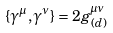Convert formula to latex. <formula><loc_0><loc_0><loc_500><loc_500>\{ \gamma ^ { \mu } , \gamma ^ { \nu } \} = 2 g ^ { \mu \nu } _ { ( d ) }</formula> 